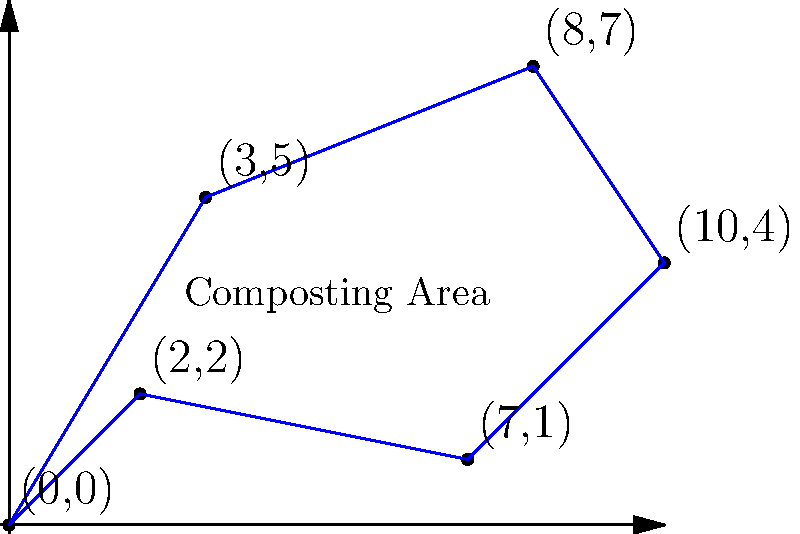The diagram shows an irregularly shaped composting area with coordinate points representing its vertices. Calculate the perimeter of this composting area to determine the length of fencing needed to enclose it. Round your answer to the nearest whole number. To calculate the perimeter, we need to find the distance between each consecutive pair of points and sum them up. We'll use the distance formula: $d = \sqrt{(x_2-x_1)^2 + (y_2-y_1)^2}$

1) Distance between (0,0) and (3,5):
   $d_1 = \sqrt{(3-0)^2 + (5-0)^2} = \sqrt{9 + 25} = \sqrt{34} \approx 5.83$

2) Distance between (3,5) and (8,7):
   $d_2 = \sqrt{(8-3)^2 + (7-5)^2} = \sqrt{25 + 4} = \sqrt{29} \approx 5.39$

3) Distance between (8,7) and (10,4):
   $d_3 = \sqrt{(10-8)^2 + (4-7)^2} = \sqrt{4 + 9} = \sqrt{13} \approx 3.61$

4) Distance between (10,4) and (7,1):
   $d_4 = \sqrt{(7-10)^2 + (1-4)^2} = \sqrt{9 + 9} = \sqrt{18} \approx 4.24$

5) Distance between (7,1) and (2,2):
   $d_5 = \sqrt{(2-7)^2 + (2-1)^2} = \sqrt{25 + 1} = \sqrt{26} \approx 5.10$

6) Distance between (2,2) and (0,0):
   $d_6 = \sqrt{(0-2)^2 + (0-2)^2} = \sqrt{4 + 4} = \sqrt{8} \approx 2.83$

Total perimeter = $d_1 + d_2 + d_3 + d_4 + d_5 + d_6$
$\approx 5.83 + 5.39 + 3.61 + 4.24 + 5.10 + 2.83 = 27$

Rounding to the nearest whole number: 27
Answer: 27 units 